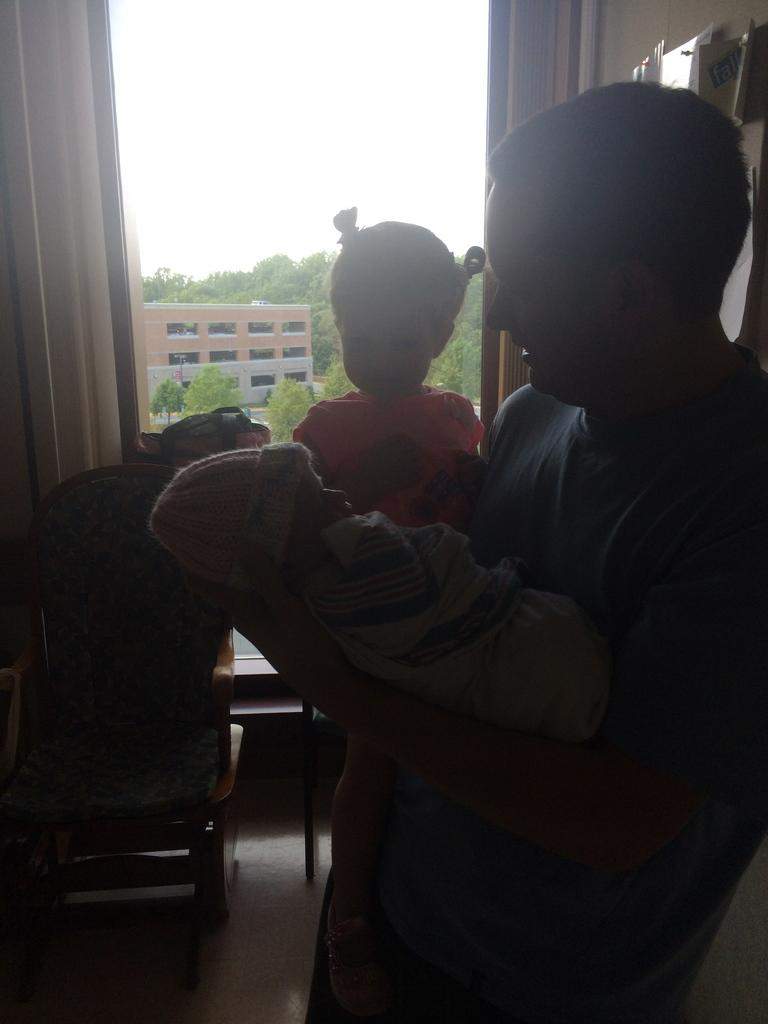Who is present in the image? There is a man in the image. What is the man holding? The man is holding a baby. What can be seen through the window in the image? Trees and the sky are visible in the image through the window. What type of base is supporting the robin in the image? There is no robin present in the image, so there is no base supporting it. 